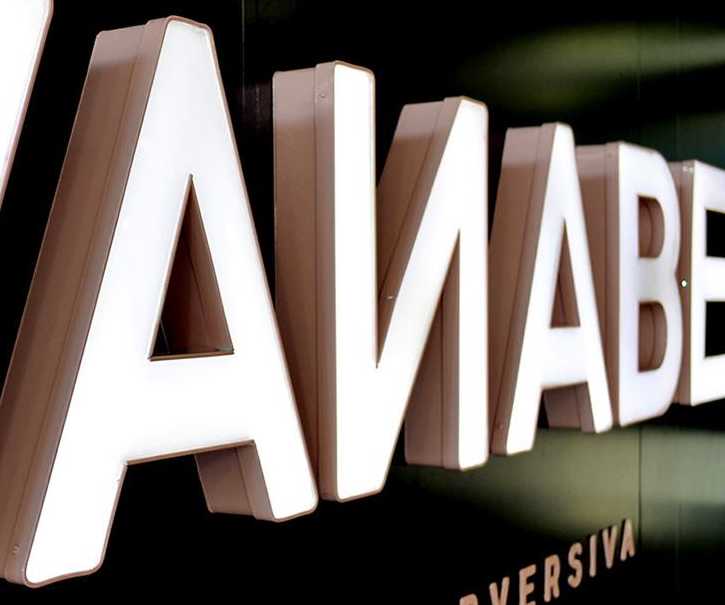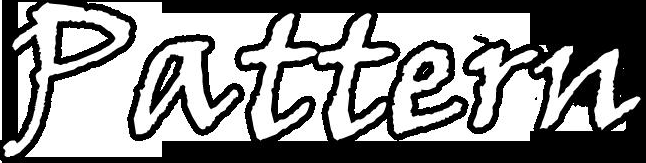Read the text content from these images in order, separated by a semicolon. AИABE; Pattern 